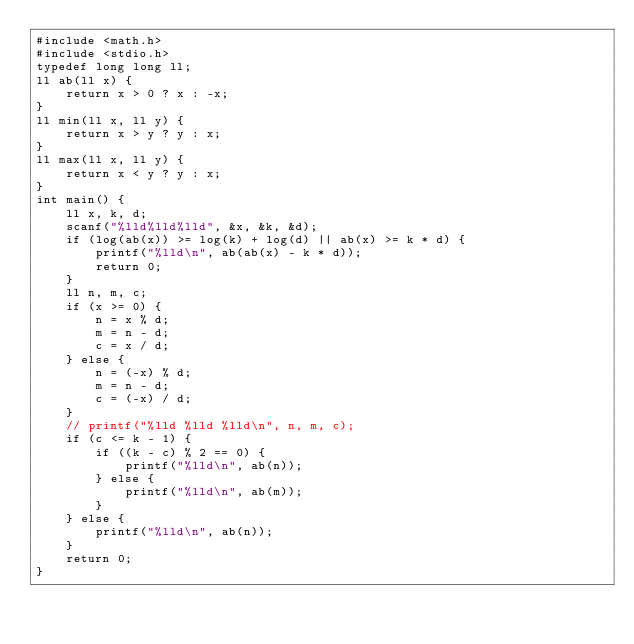<code> <loc_0><loc_0><loc_500><loc_500><_C_>#include <math.h>
#include <stdio.h>
typedef long long ll;
ll ab(ll x) {
	return x > 0 ? x : -x;
}
ll min(ll x, ll y) {
	return x > y ? y : x;
}
ll max(ll x, ll y) {
	return x < y ? y : x;
}
int main() {
	ll x, k, d;
	scanf("%lld%lld%lld", &x, &k, &d);
	if (log(ab(x)) >= log(k) + log(d) || ab(x) >= k * d) {
		printf("%lld\n", ab(ab(x) - k * d));
		return 0;
	}
	ll n, m, c;
	if (x >= 0) {
		n = x % d;
		m = n - d;
		c = x / d;
	} else {
		n = (-x) % d;
		m = n - d;
		c = (-x) / d;
	}
	// printf("%lld %lld %lld\n", n, m, c);
	if (c <= k - 1) {
		if ((k - c) % 2 == 0) {
			printf("%lld\n", ab(n));
		} else {
			printf("%lld\n", ab(m));
		}
	} else {
		printf("%lld\n", ab(n));
	}
	return 0;
}</code> 